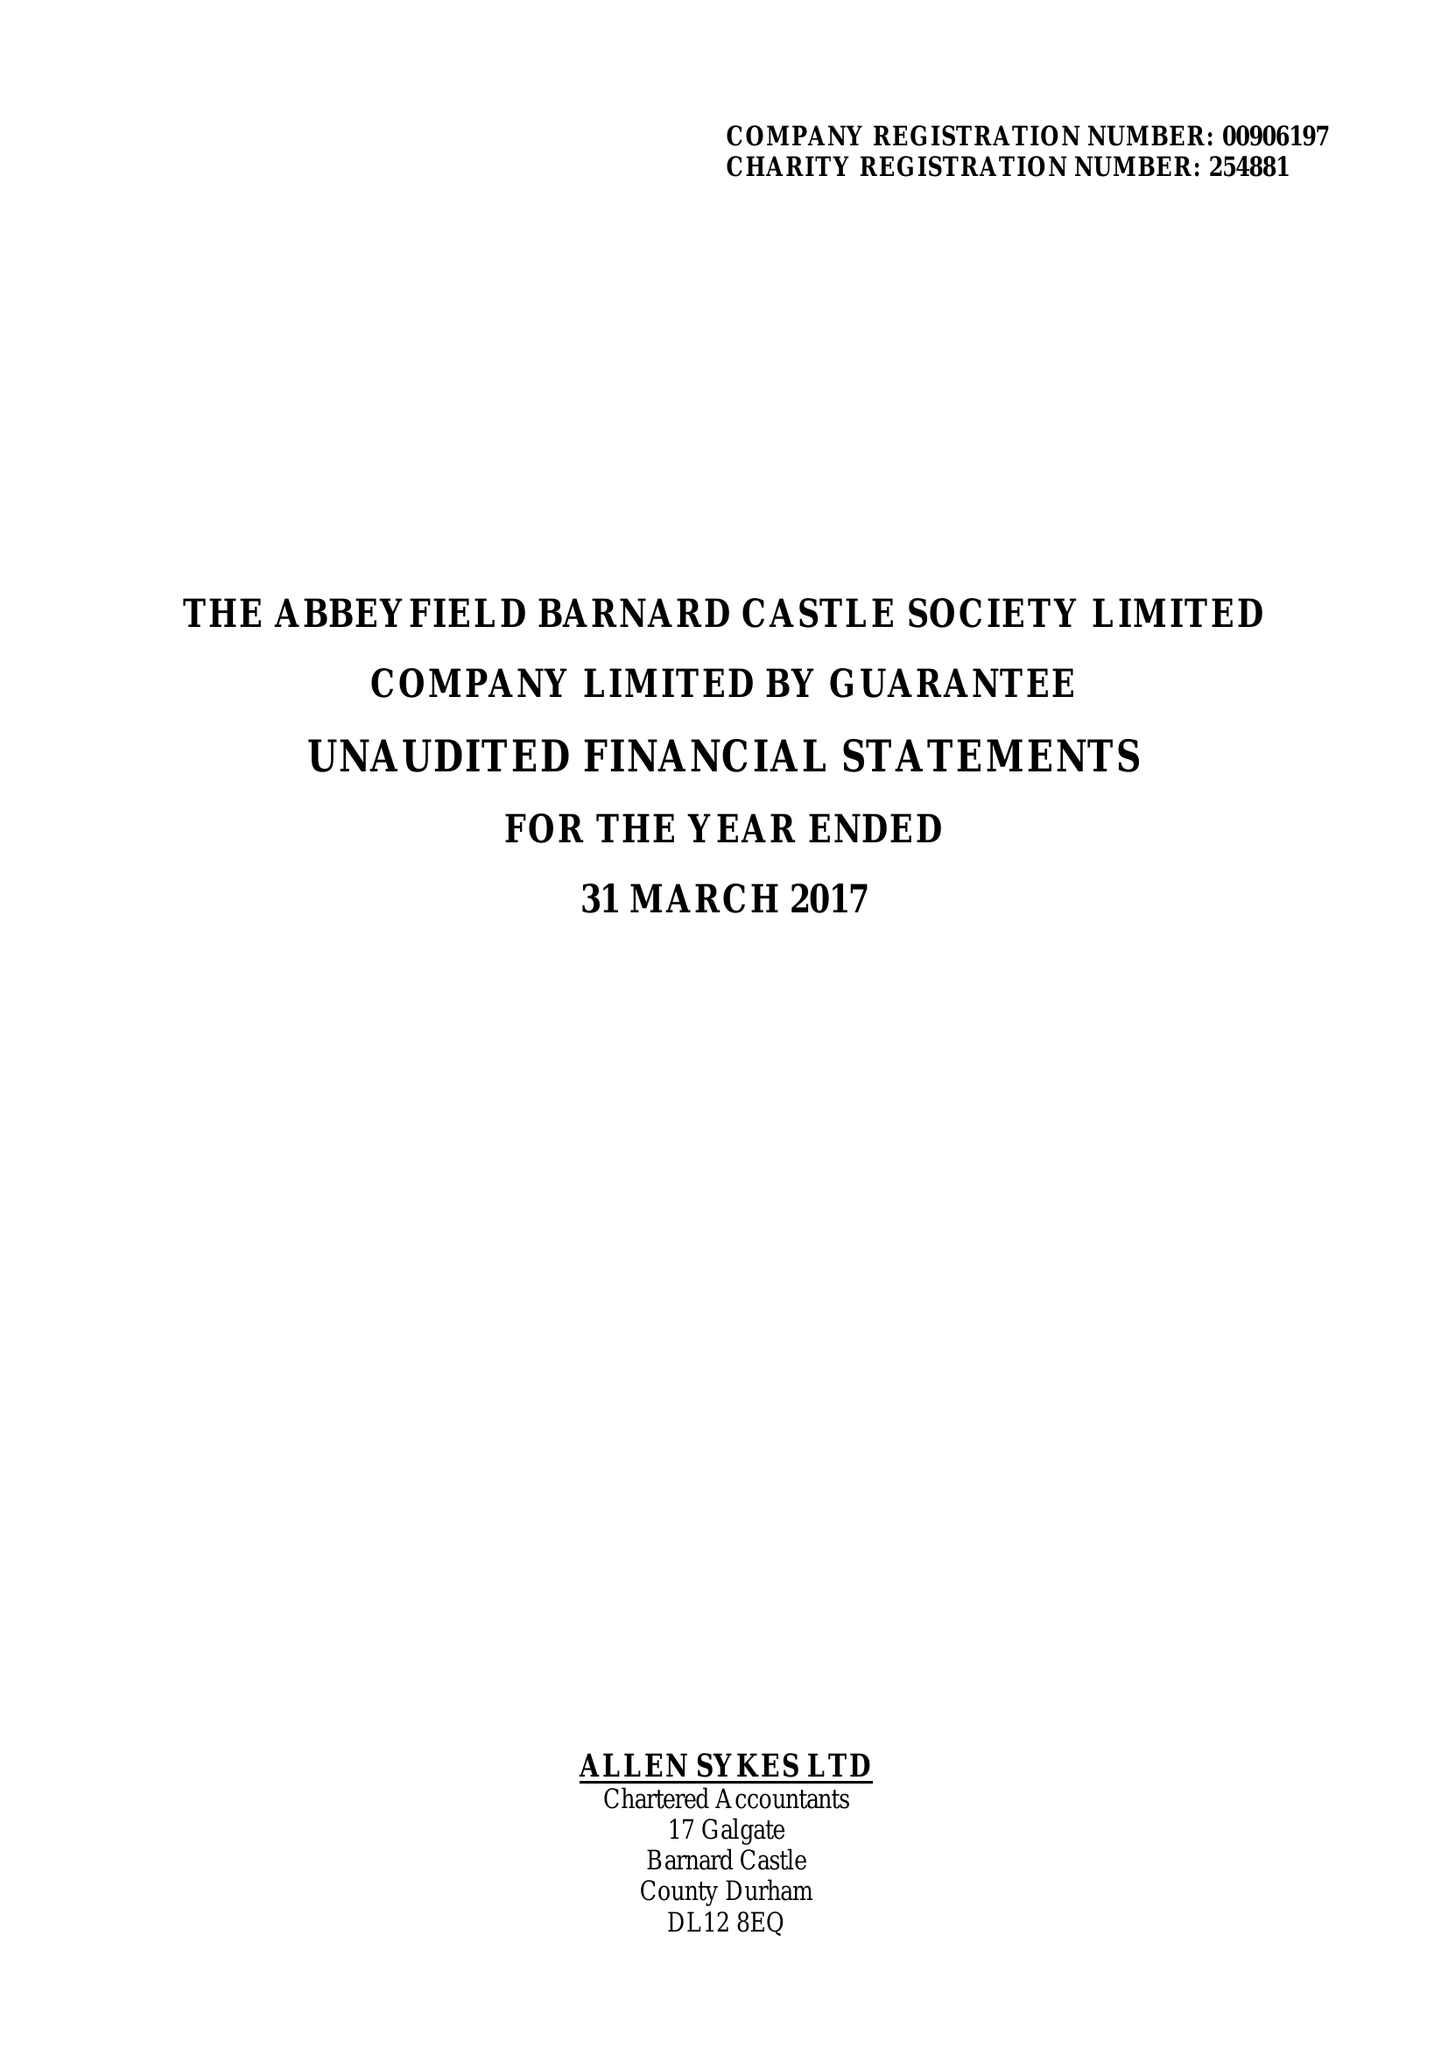What is the value for the charity_name?
Answer the question using a single word or phrase. The Abbeyfield Barnard Castle Society Ltd. 